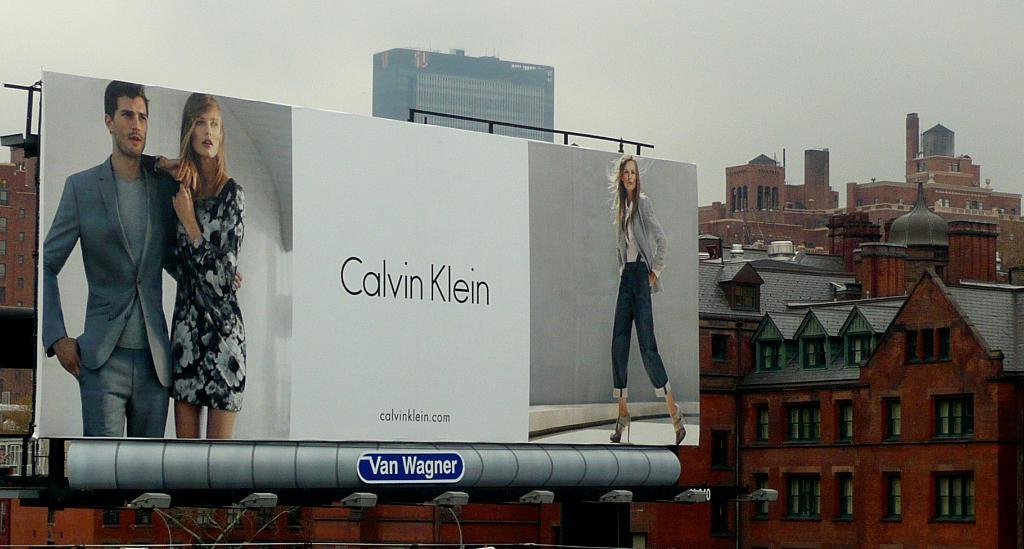<image>
Write a terse but informative summary of the picture. A Calvin Klein billboard shows three models in different outfits. 